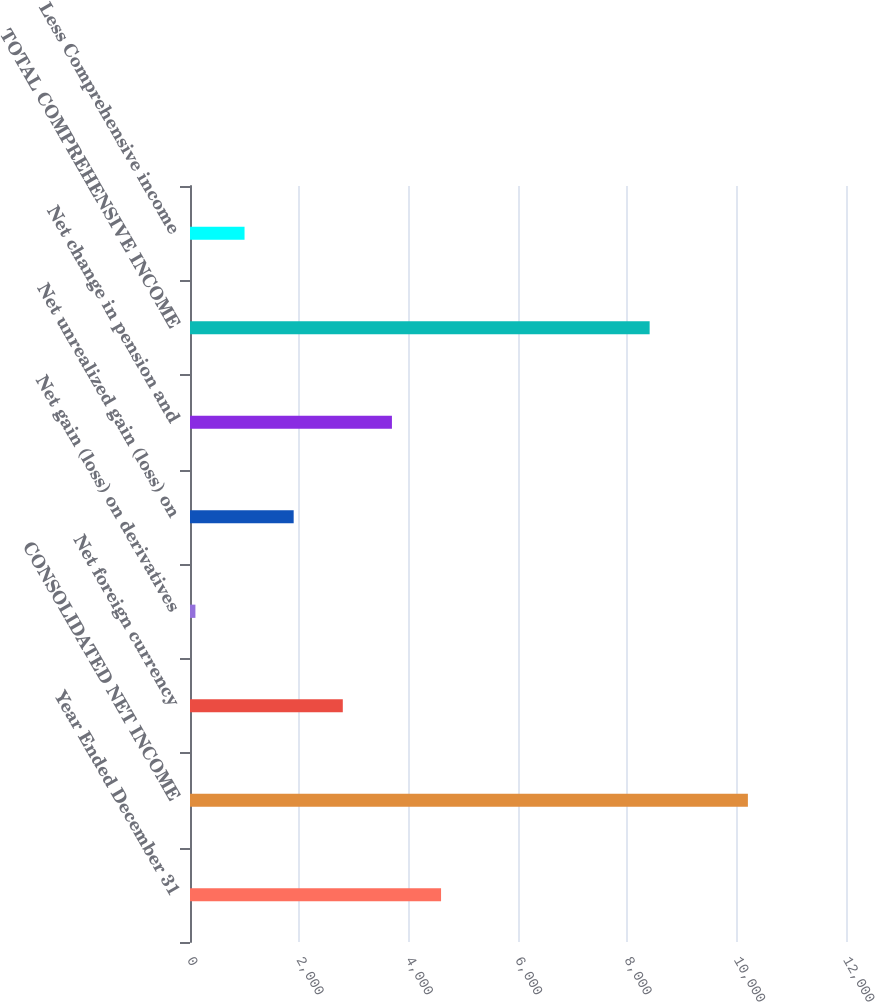Convert chart to OTSL. <chart><loc_0><loc_0><loc_500><loc_500><bar_chart><fcel>Year Ended December 31<fcel>CONSOLIDATED NET INCOME<fcel>Net foreign currency<fcel>Net gain (loss) on derivatives<fcel>Net unrealized gain (loss) on<fcel>Net change in pension and<fcel>TOTAL COMPREHENSIVE INCOME<fcel>Less Comprehensive income<nl><fcel>4592.5<fcel>10205.4<fcel>2795.1<fcel>99<fcel>1896.4<fcel>3693.8<fcel>8408<fcel>997.7<nl></chart> 